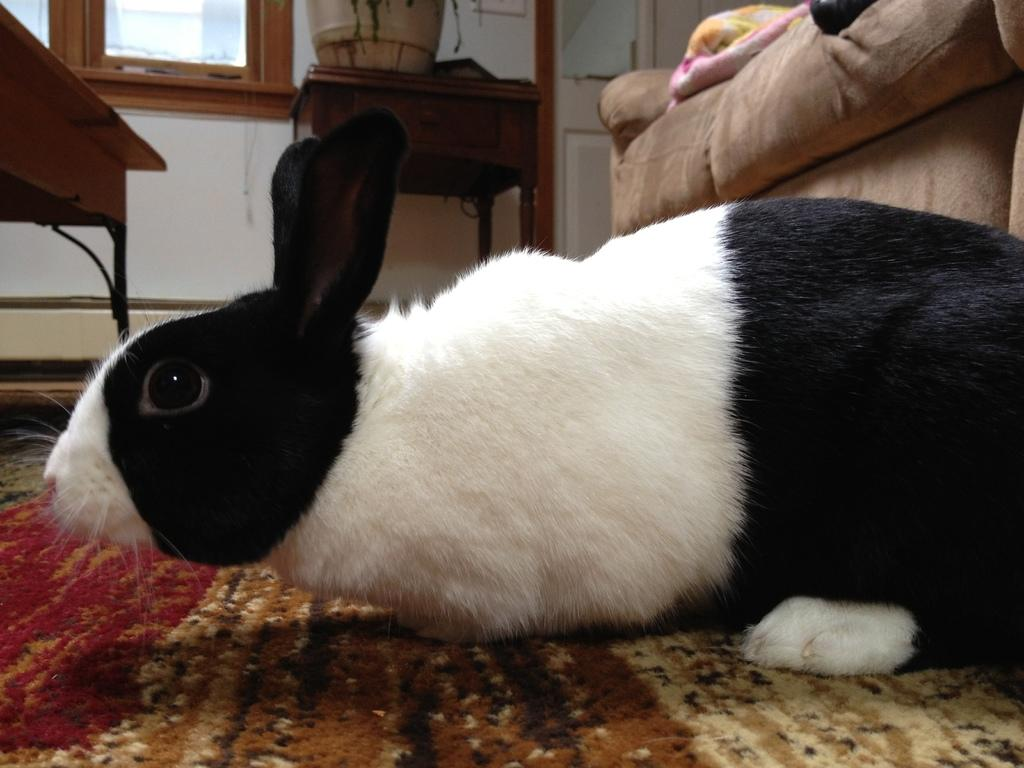What animal is on the floor in the image? There is a rabbit on the floor in the image. What type of furniture is present in the image? There is a couch and a table in the image. What type of business is being conducted in the image? There is no indication of any business being conducted in the image; it features a rabbit on the floor and furniture. 